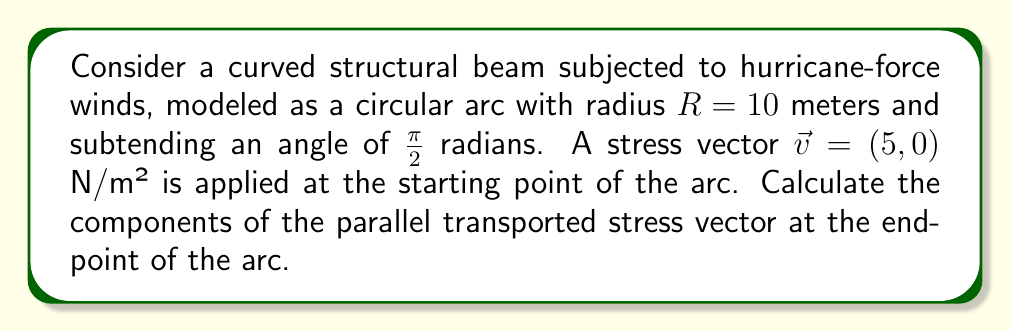Could you help me with this problem? To solve this problem, we'll use the principles of parallel transport along a curved surface. For a circular arc, we can use the following steps:

1) First, we need to set up our coordinate system. Let's use polar coordinates $(r, \theta)$ with the center of the circle at the origin.

2) The parallel transport equation for a vector $\vec{v} = (v_r, v_\theta)$ along a circular arc is:

   $$\frac{d}{d\theta}\begin{pmatrix}v_r \\ v_\theta\end{pmatrix} = \begin{pmatrix}0 & -1 \\ 1 & 0\end{pmatrix}\begin{pmatrix}v_r \\ v_\theta\end{pmatrix}$$

3) This system of differential equations can be solved to give:

   $$v_r(\theta) = v_r(0)\cos\theta + v_\theta(0)\sin\theta$$
   $$v_\theta(\theta) = -v_r(0)\sin\theta + v_\theta(0)\cos\theta$$

4) In our case, $v_r(0) = 5$ and $v_\theta(0) = 0$. The arc subtends an angle of $\frac{\pi}{2}$, so we need to evaluate at $\theta = \frac{\pi}{2}$:

   $$v_r(\frac{\pi}{2}) = 5\cos(\frac{\pi}{2}) + 0\sin(\frac{\pi}{2}) = 0$$
   $$v_\theta(\frac{\pi}{2}) = -5\sin(\frac{\pi}{2}) + 0\cos(\frac{\pi}{2}) = -5$$

5) Now, we need to convert back to Cartesian coordinates. At $\theta = \frac{\pi}{2}$, the radial direction aligns with the y-axis and the tangential direction aligns with the negative x-axis:

   $$v_x = -v_\theta = 5$$
   $$v_y = v_r = 0$$

Therefore, the parallel transported stress vector at the endpoint of the arc is $(5, 0)$ N/m².
Answer: $(5, 0)$ N/m² 